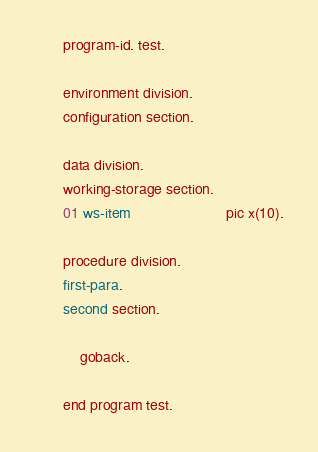Convert code to text. <code><loc_0><loc_0><loc_500><loc_500><_COBOL_>       program-id. test.

       environment division.
       configuration section.

       data division.
       working-storage section.
       01 ws-item                       pic x(10).

       procedure division.
       first-para.
       second section.

           goback.

       end program test.
</code> 